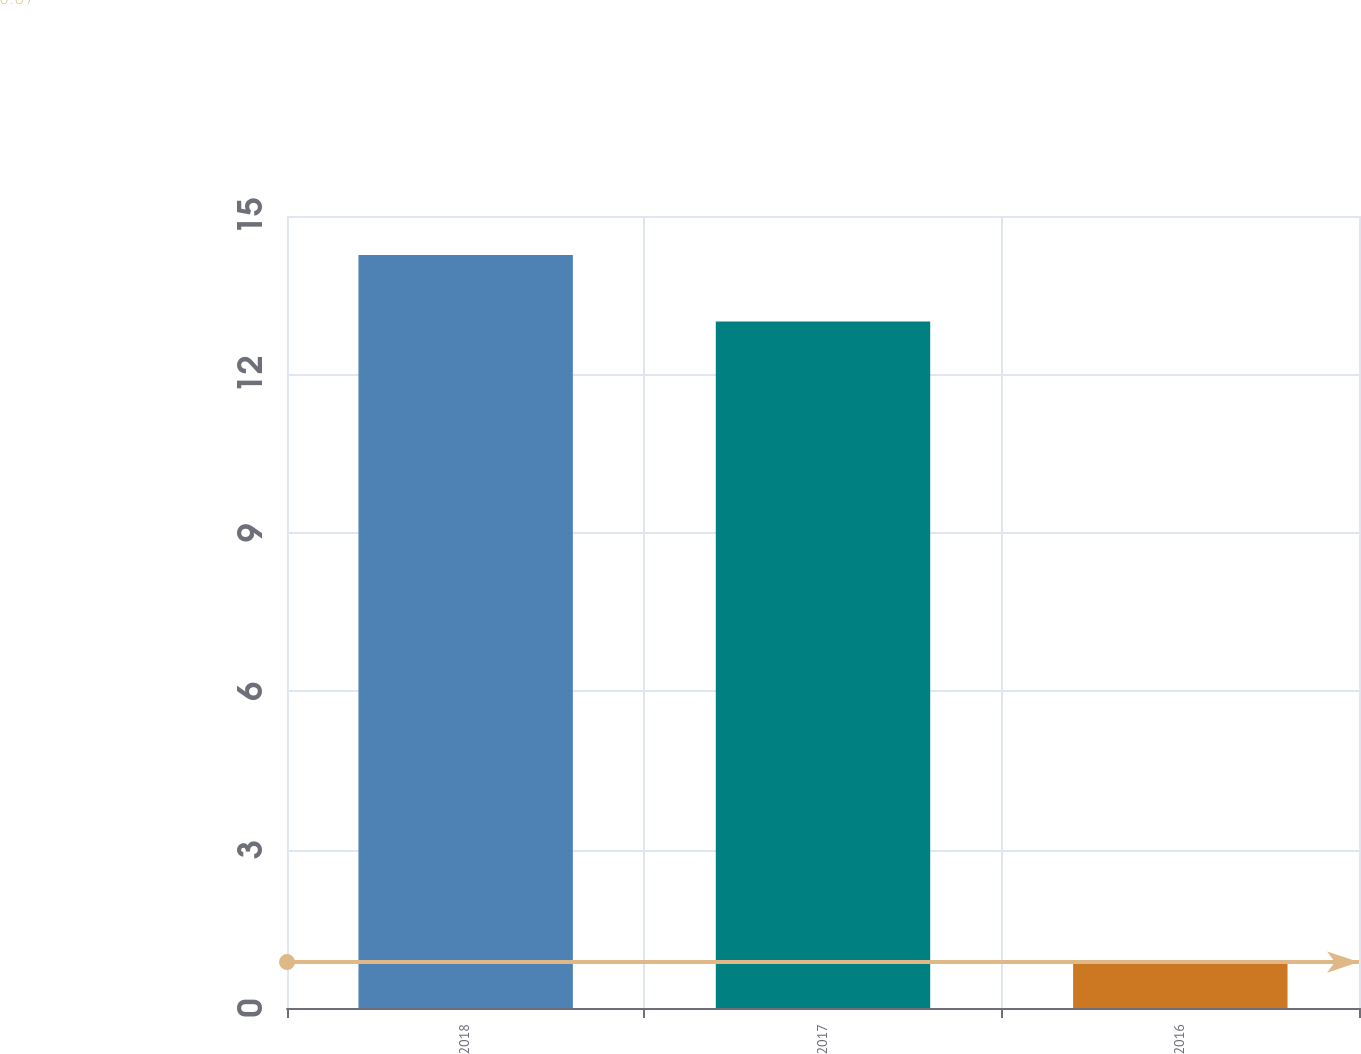Convert chart to OTSL. <chart><loc_0><loc_0><loc_500><loc_500><bar_chart><fcel>2018<fcel>2017<fcel>2016<nl><fcel>14.26<fcel>13<fcel>0.87<nl></chart> 